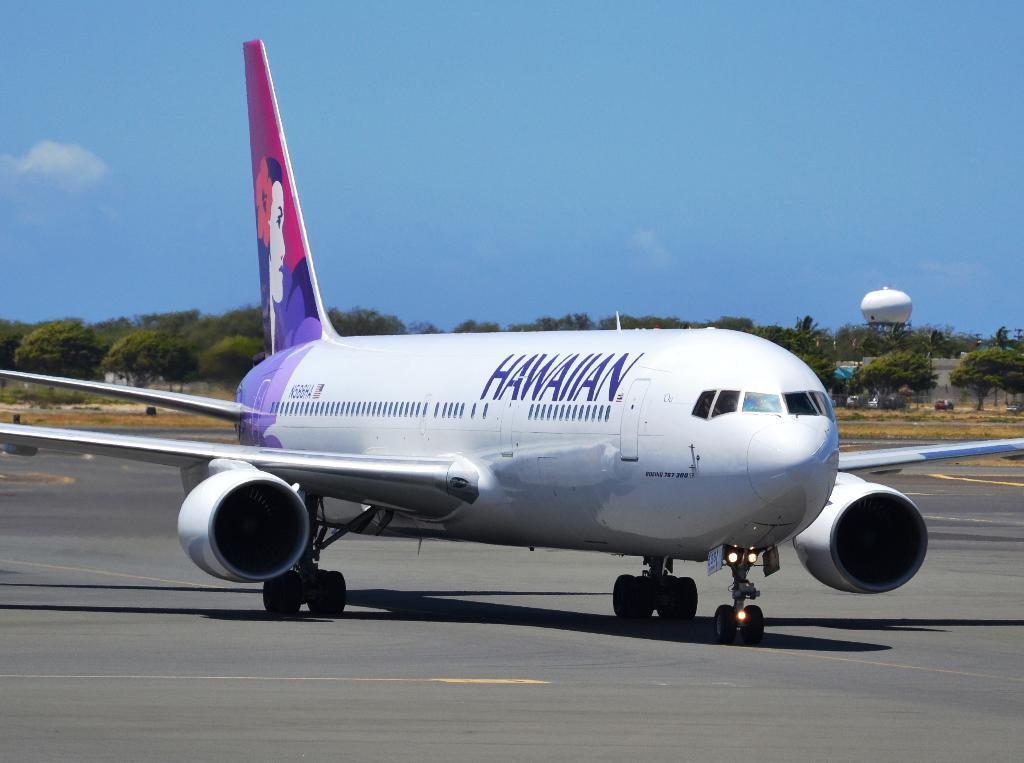<image>
Offer a succinct explanation of the picture presented. A Hawaiian airlines flight makes it way down the runway for takeoff on a beautiful day 